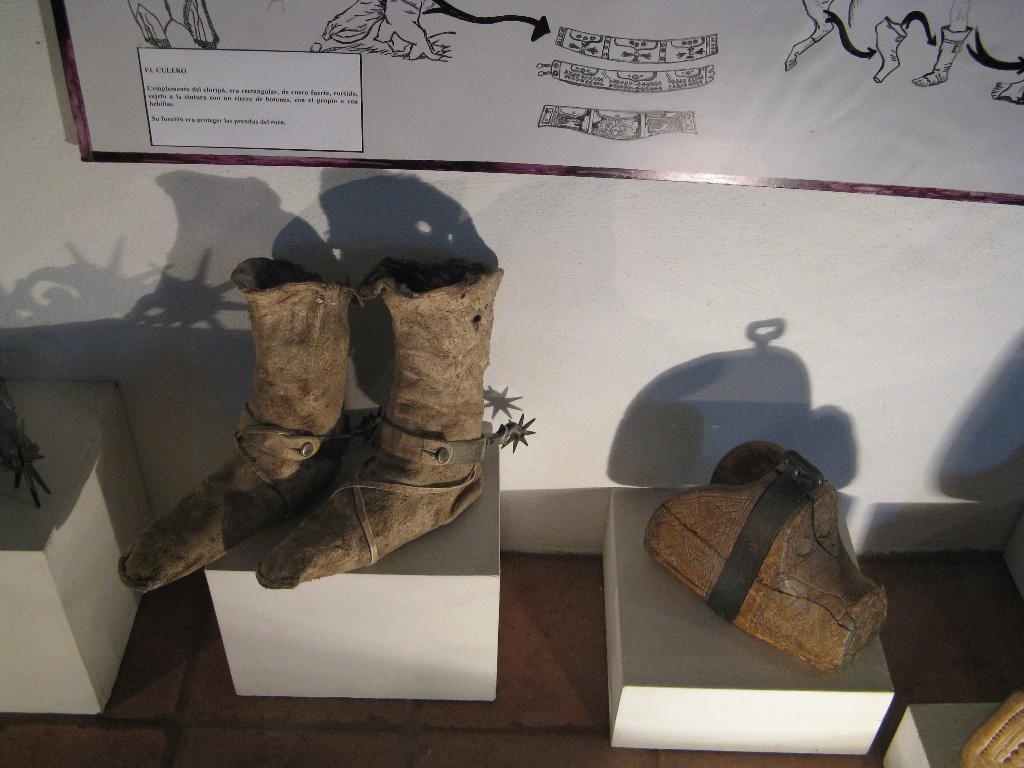What type of objects can be seen in the image? There are shoes and small tables with objects on them in the image. What is visible on the wall in the background? There is a board with text and drawings on the wall. Can you describe the small tables in the image? The small tables have objects on them, but the specific objects are not mentioned in the facts. Are the friends playing baseball in the image? There is no mention of friends or baseball in the image, so we cannot determine if they are present or playing baseball. 